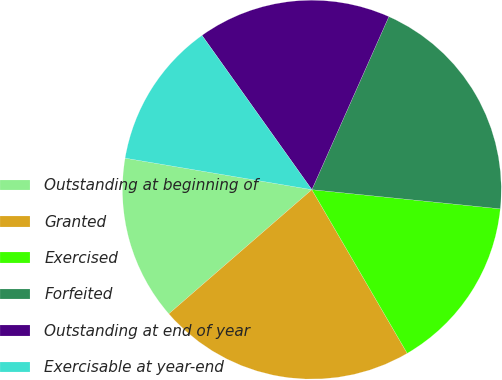<chart> <loc_0><loc_0><loc_500><loc_500><pie_chart><fcel>Outstanding at beginning of<fcel>Granted<fcel>Exercised<fcel>Forfeited<fcel>Outstanding at end of year<fcel>Exercisable at year-end<nl><fcel>14.04%<fcel>22.02%<fcel>14.99%<fcel>19.95%<fcel>16.51%<fcel>12.49%<nl></chart> 